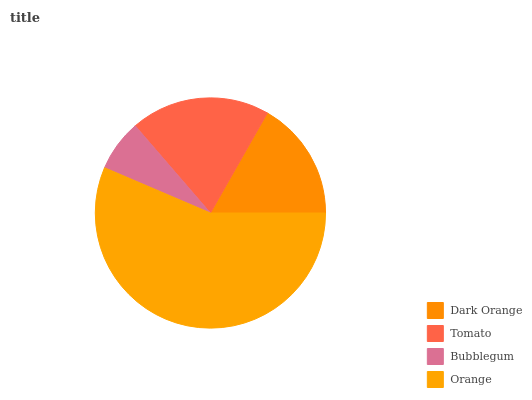Is Bubblegum the minimum?
Answer yes or no. Yes. Is Orange the maximum?
Answer yes or no. Yes. Is Tomato the minimum?
Answer yes or no. No. Is Tomato the maximum?
Answer yes or no. No. Is Tomato greater than Dark Orange?
Answer yes or no. Yes. Is Dark Orange less than Tomato?
Answer yes or no. Yes. Is Dark Orange greater than Tomato?
Answer yes or no. No. Is Tomato less than Dark Orange?
Answer yes or no. No. Is Tomato the high median?
Answer yes or no. Yes. Is Dark Orange the low median?
Answer yes or no. Yes. Is Bubblegum the high median?
Answer yes or no. No. Is Tomato the low median?
Answer yes or no. No. 